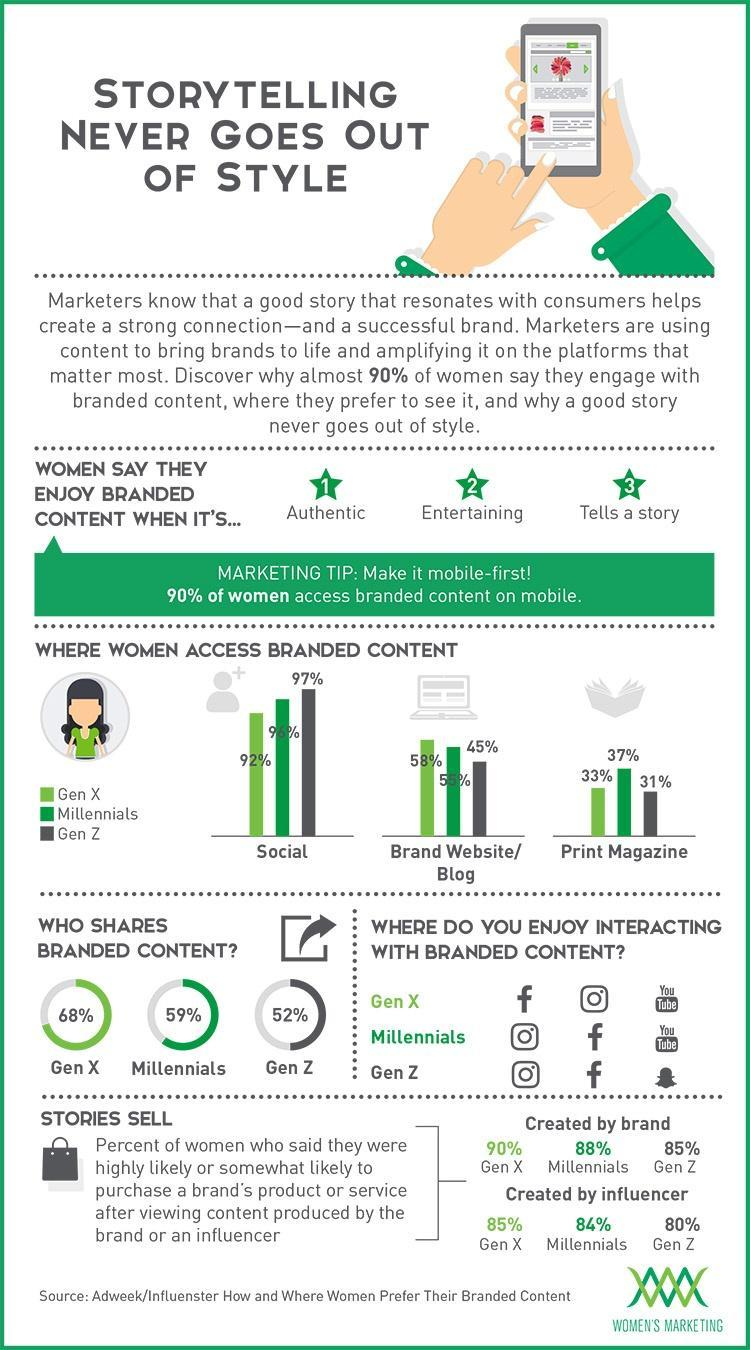Where do most Gen Z women access branded content, Social Media, Brand Website, or Print Magazine?
Answer the question with a short phrase. Social Media Which of the three, shares branded content the most, Gen X, Millenials, or Gen Z? Gen X What percentile of Millennial women bought products after being influenced by brand stories created by influencers, 88%, 85%, 84%, or 80%? 84% Which is the second most preferred social media tool by Gen Z and Millennials, Instagram, Facebook, or YouTube? Facebook What is the percentage of millennials accessing a blog? 55% Which is the third most preferred social media tool by Gen Z, Snapchat, Instagram, Facebook, or YouTube? Snapchat What is the percentage of Gen X accessing a print magazine? 33% Where do most Millennials like interacting with branded content, Instagram, Facebook, or YouTube ? Instagram Who among the three uses Social Media the least GenX, Millennials, or Gen Z? Gen X 